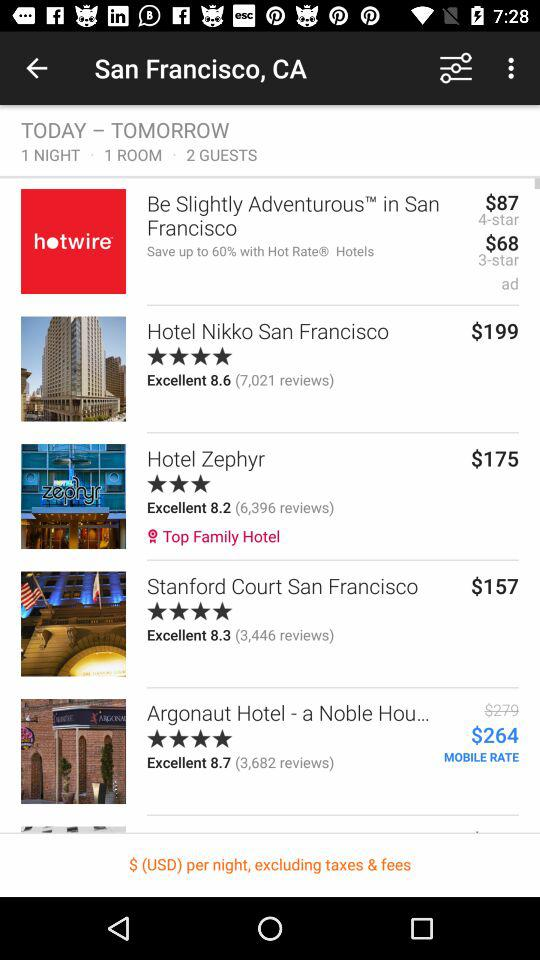What is the booking price of a room at "Hotel Zephyr"? The booking price of a room at "Hotel Zephyr" is $175. 